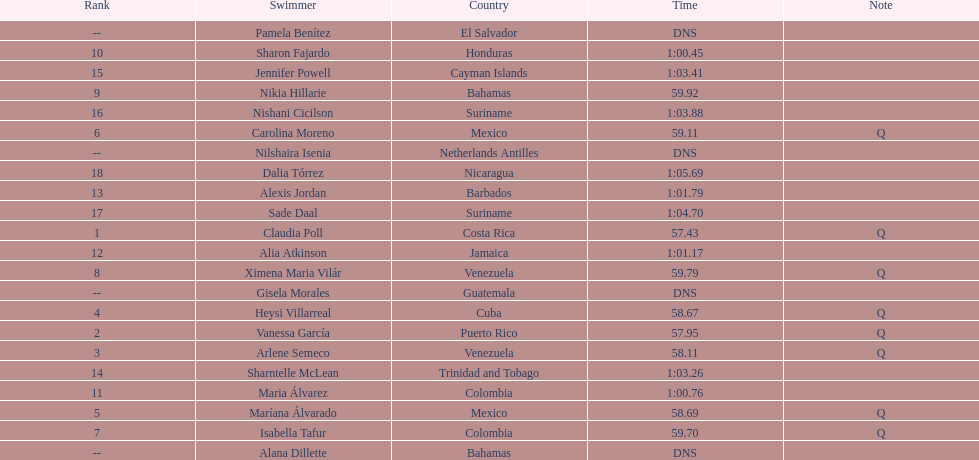What swimmer had the top or first rank? Claudia Poll. 